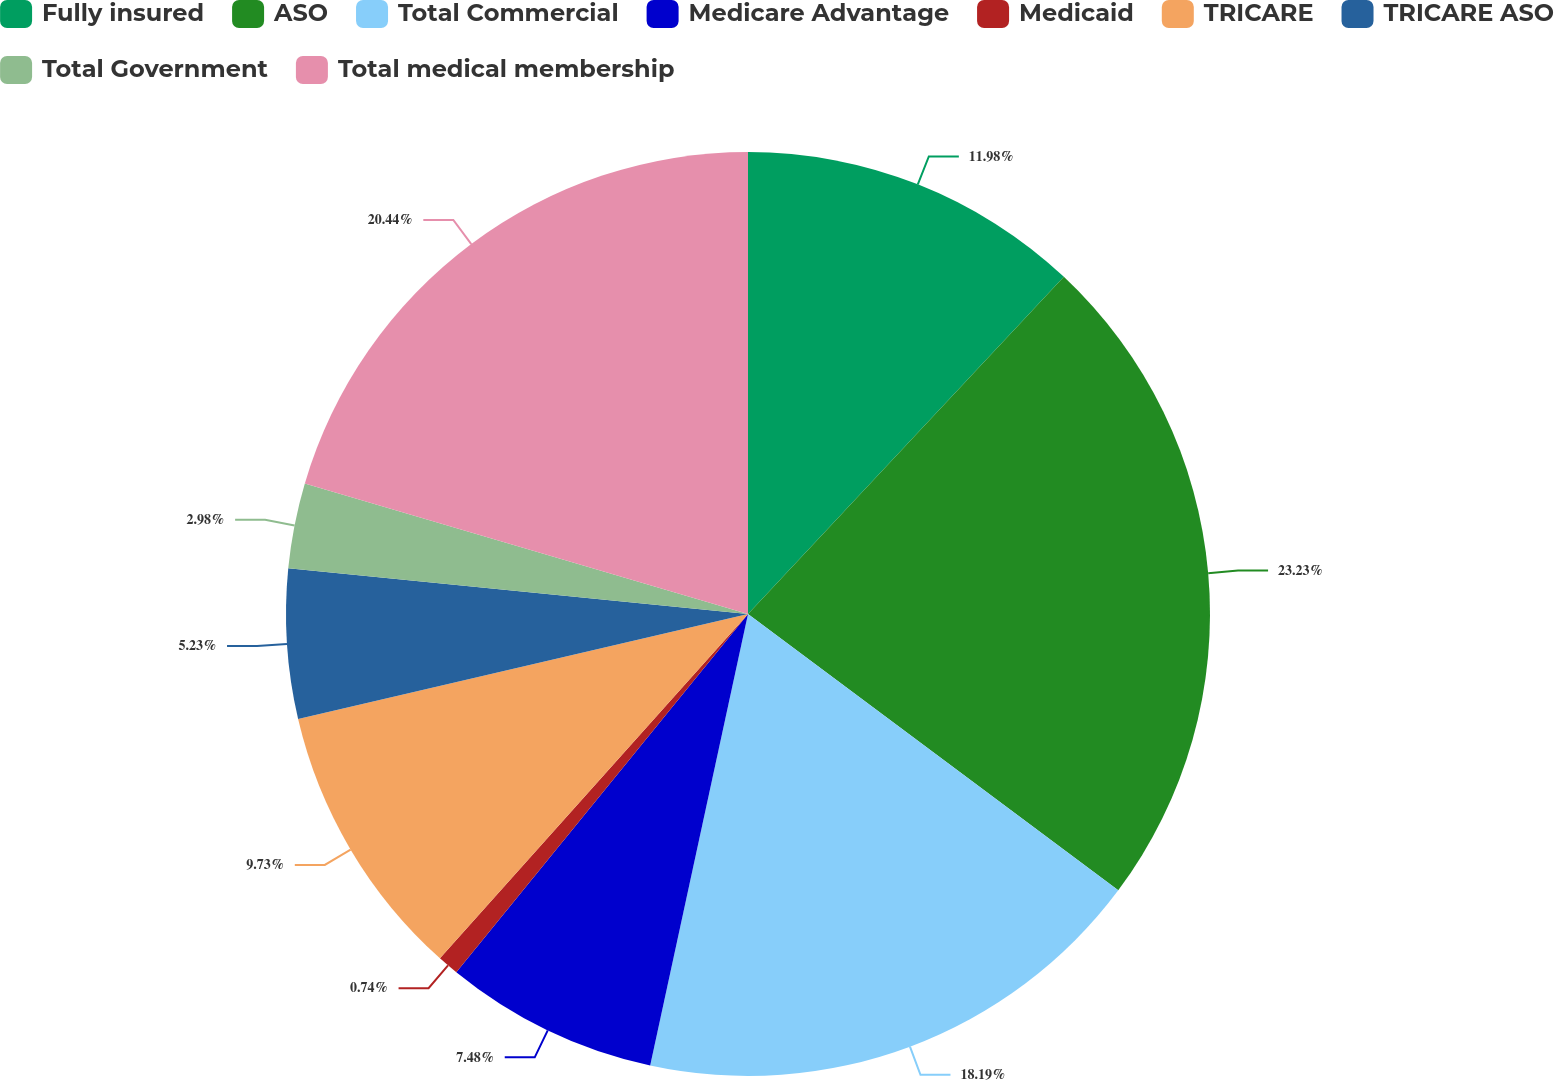<chart> <loc_0><loc_0><loc_500><loc_500><pie_chart><fcel>Fully insured<fcel>ASO<fcel>Total Commercial<fcel>Medicare Advantage<fcel>Medicaid<fcel>TRICARE<fcel>TRICARE ASO<fcel>Total Government<fcel>Total medical membership<nl><fcel>11.98%<fcel>23.22%<fcel>18.19%<fcel>7.48%<fcel>0.74%<fcel>9.73%<fcel>5.23%<fcel>2.98%<fcel>20.44%<nl></chart> 